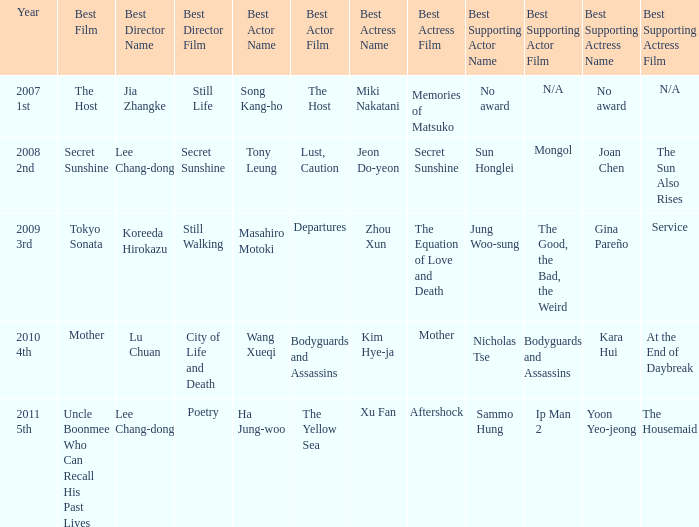Name the best actor for uncle boonmee who can recall his past lives Ha Jung-woo for The Yellow Sea. 